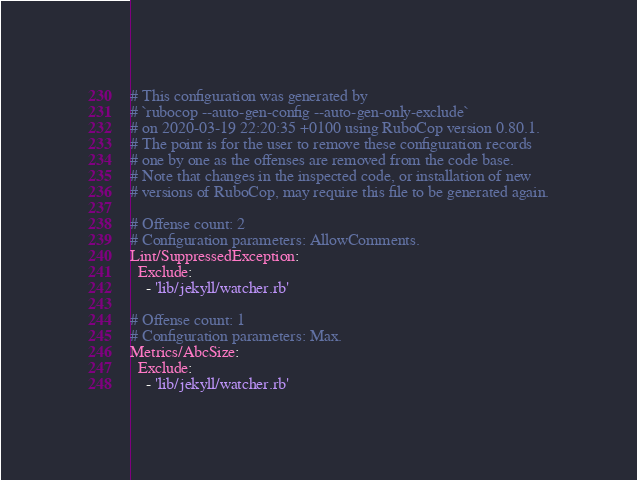<code> <loc_0><loc_0><loc_500><loc_500><_YAML_># This configuration was generated by
# `rubocop --auto-gen-config --auto-gen-only-exclude`
# on 2020-03-19 22:20:35 +0100 using RuboCop version 0.80.1.
# The point is for the user to remove these configuration records
# one by one as the offenses are removed from the code base.
# Note that changes in the inspected code, or installation of new
# versions of RuboCop, may require this file to be generated again.

# Offense count: 2
# Configuration parameters: AllowComments.
Lint/SuppressedException:
  Exclude:
    - 'lib/jekyll/watcher.rb'

# Offense count: 1
# Configuration parameters: Max.
Metrics/AbcSize:
  Exclude:
    - 'lib/jekyll/watcher.rb'
</code> 